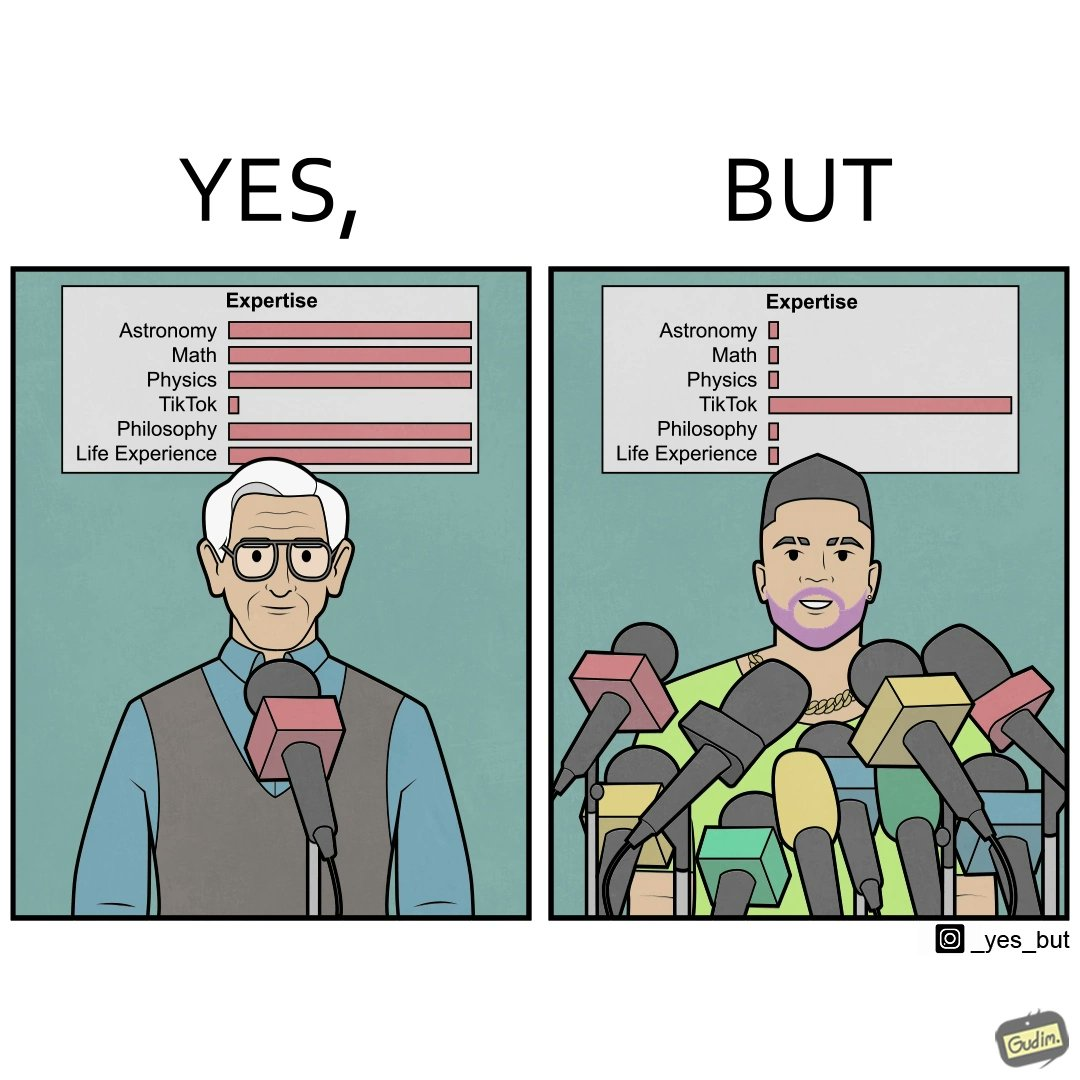Is this a satirical image? Yes, this image is satirical. 